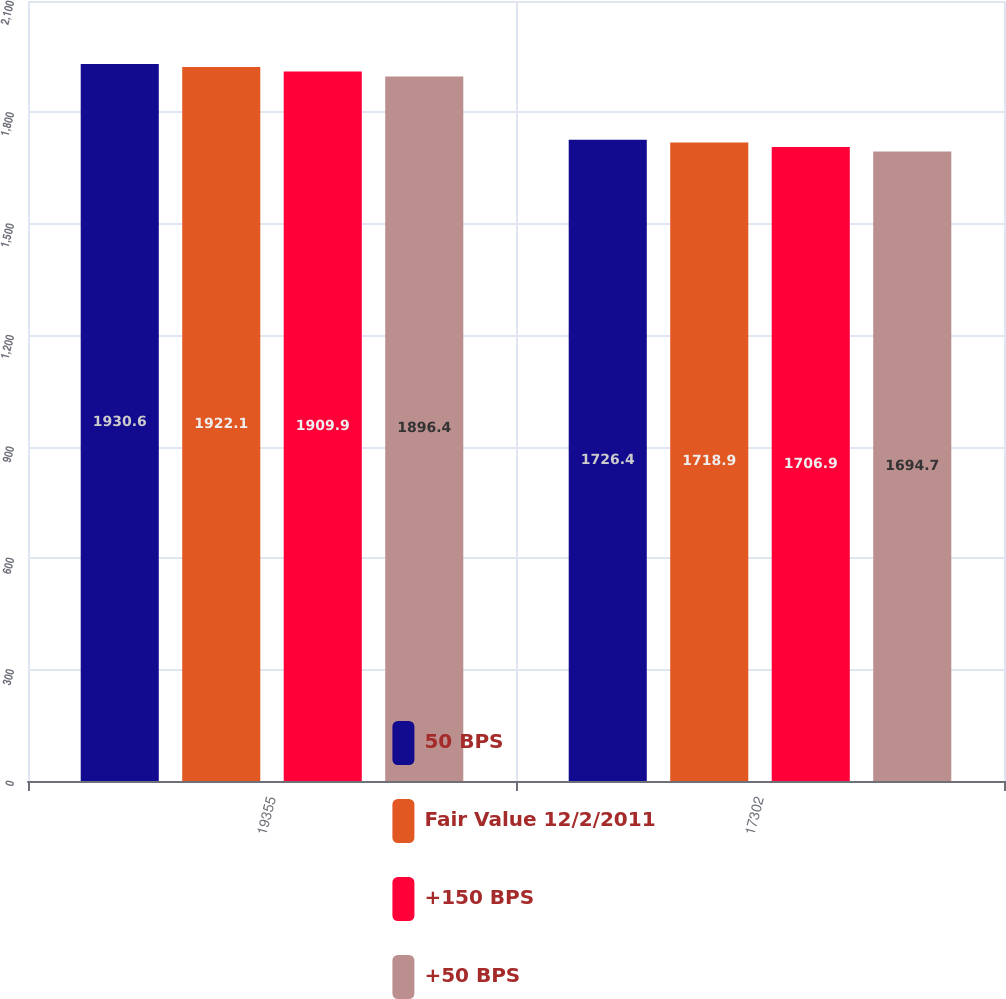Convert chart to OTSL. <chart><loc_0><loc_0><loc_500><loc_500><stacked_bar_chart><ecel><fcel>19355<fcel>17302<nl><fcel>50 BPS<fcel>1930.6<fcel>1726.4<nl><fcel>Fair Value 12/2/2011<fcel>1922.1<fcel>1718.9<nl><fcel>+150 BPS<fcel>1909.9<fcel>1706.9<nl><fcel>+50 BPS<fcel>1896.4<fcel>1694.7<nl></chart> 